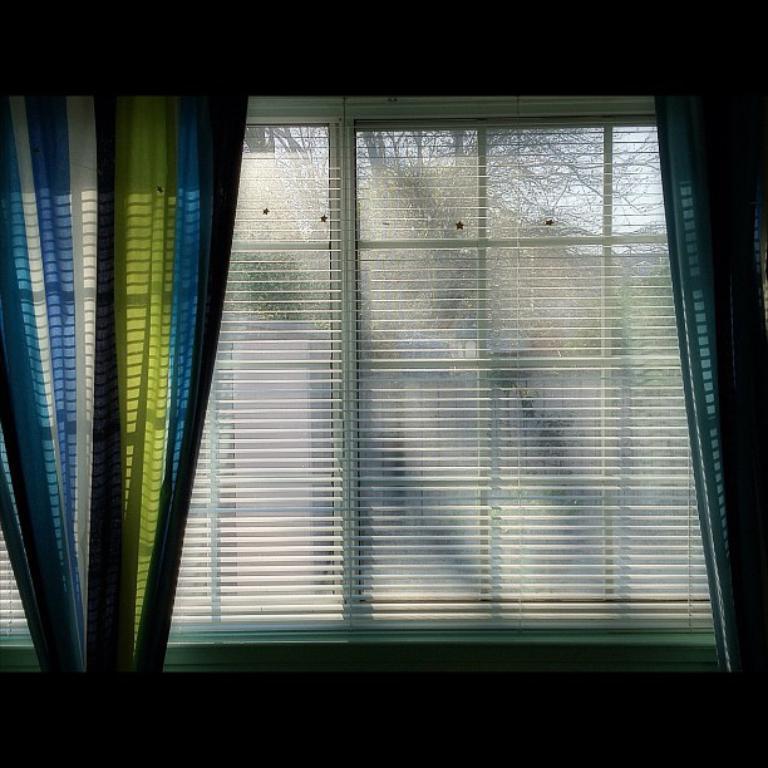Describe this image in one or two sentences. In the given image i can see a curtains,window and behind the window i can see a trees. 